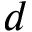Convert formula to latex. <formula><loc_0><loc_0><loc_500><loc_500>d</formula> 